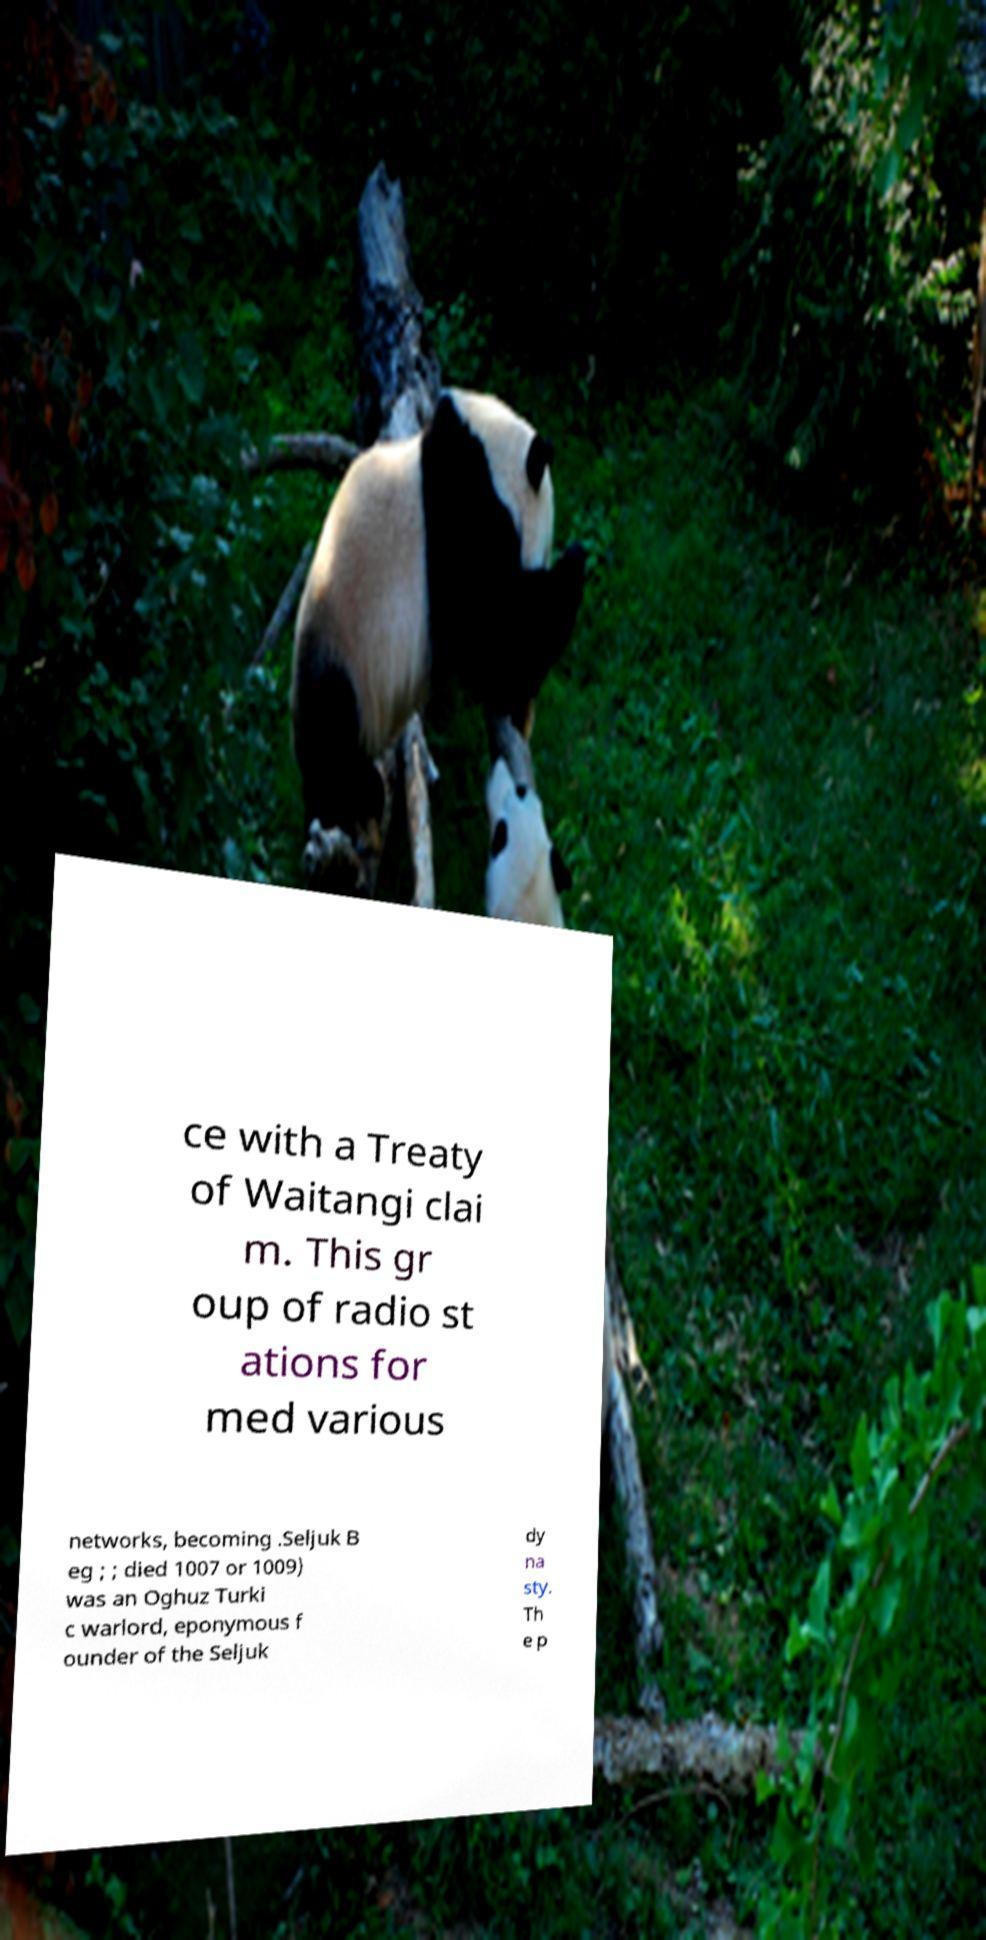There's text embedded in this image that I need extracted. Can you transcribe it verbatim? ce with a Treaty of Waitangi clai m. This gr oup of radio st ations for med various networks, becoming .Seljuk B eg ; ; died 1007 or 1009) was an Oghuz Turki c warlord, eponymous f ounder of the Seljuk dy na sty. Th e p 